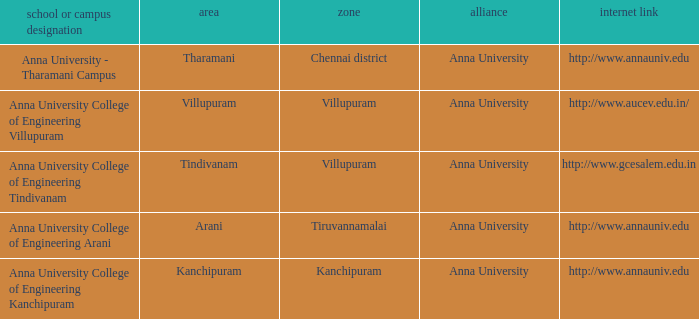What District has a Location of tharamani? Chennai district. 